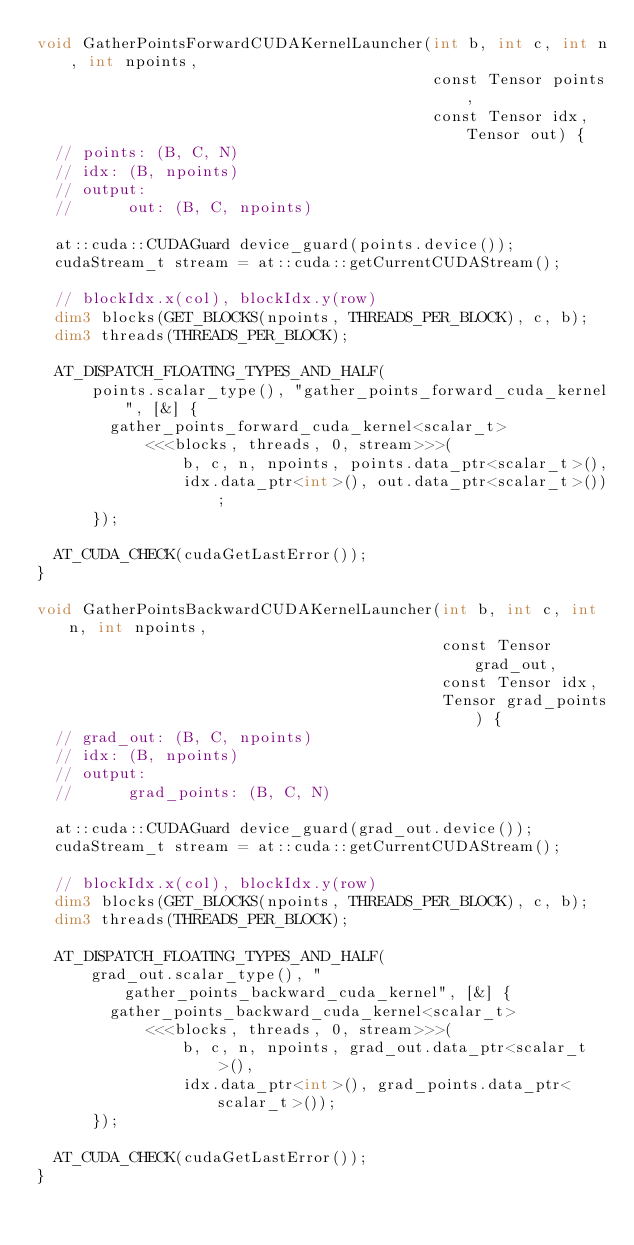Convert code to text. <code><loc_0><loc_0><loc_500><loc_500><_Cuda_>void GatherPointsForwardCUDAKernelLauncher(int b, int c, int n, int npoints,
                                           const Tensor points,
                                           const Tensor idx, Tensor out) {
  // points: (B, C, N)
  // idx: (B, npoints)
  // output:
  //      out: (B, C, npoints)

  at::cuda::CUDAGuard device_guard(points.device());
  cudaStream_t stream = at::cuda::getCurrentCUDAStream();

  // blockIdx.x(col), blockIdx.y(row)
  dim3 blocks(GET_BLOCKS(npoints, THREADS_PER_BLOCK), c, b);
  dim3 threads(THREADS_PER_BLOCK);

  AT_DISPATCH_FLOATING_TYPES_AND_HALF(
      points.scalar_type(), "gather_points_forward_cuda_kernel", [&] {
        gather_points_forward_cuda_kernel<scalar_t>
            <<<blocks, threads, 0, stream>>>(
                b, c, n, npoints, points.data_ptr<scalar_t>(),
                idx.data_ptr<int>(), out.data_ptr<scalar_t>());
      });

  AT_CUDA_CHECK(cudaGetLastError());
}

void GatherPointsBackwardCUDAKernelLauncher(int b, int c, int n, int npoints,
                                            const Tensor grad_out,
                                            const Tensor idx,
                                            Tensor grad_points) {
  // grad_out: (B, C, npoints)
  // idx: (B, npoints)
  // output:
  //      grad_points: (B, C, N)

  at::cuda::CUDAGuard device_guard(grad_out.device());
  cudaStream_t stream = at::cuda::getCurrentCUDAStream();

  // blockIdx.x(col), blockIdx.y(row)
  dim3 blocks(GET_BLOCKS(npoints, THREADS_PER_BLOCK), c, b);
  dim3 threads(THREADS_PER_BLOCK);

  AT_DISPATCH_FLOATING_TYPES_AND_HALF(
      grad_out.scalar_type(), "gather_points_backward_cuda_kernel", [&] {
        gather_points_backward_cuda_kernel<scalar_t>
            <<<blocks, threads, 0, stream>>>(
                b, c, n, npoints, grad_out.data_ptr<scalar_t>(),
                idx.data_ptr<int>(), grad_points.data_ptr<scalar_t>());
      });

  AT_CUDA_CHECK(cudaGetLastError());
}
</code> 